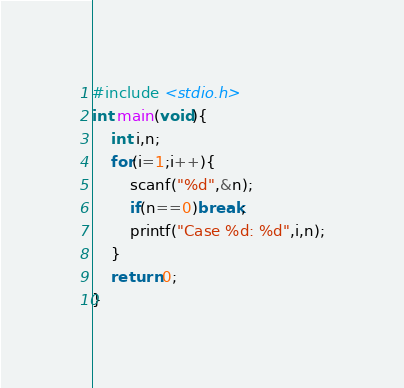<code> <loc_0><loc_0><loc_500><loc_500><_C_>#include <stdio.h>
int main(void){
    int i,n;
    for(i=1;i++){
        scanf("%d",&n);
        if(n==0)break;
        printf("Case %d: %d",i,n);
    }
    return 0;
}
</code> 